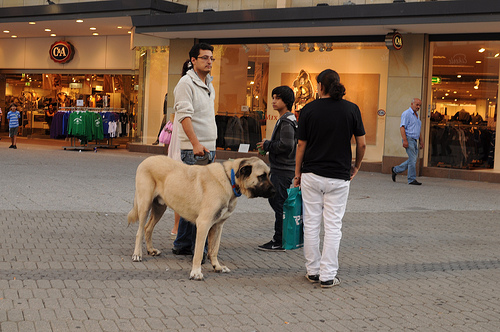Is the animal to the left of the bag small or large? The animal to the left of the bag is large, specifically a big dog with a noticeable presence. 